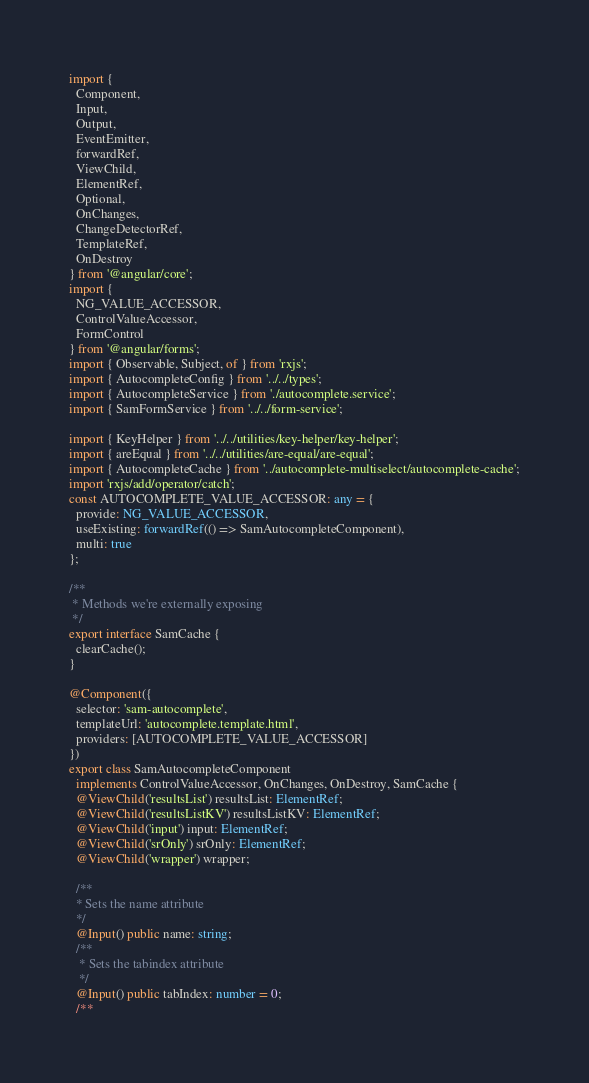<code> <loc_0><loc_0><loc_500><loc_500><_TypeScript_>import {
  Component,
  Input,
  Output,
  EventEmitter,
  forwardRef,
  ViewChild,
  ElementRef,
  Optional,
  OnChanges,
  ChangeDetectorRef,
  TemplateRef,
  OnDestroy
} from '@angular/core';
import {
  NG_VALUE_ACCESSOR,
  ControlValueAccessor,
  FormControl
} from '@angular/forms';
import { Observable, Subject, of } from 'rxjs';
import { AutocompleteConfig } from '../../types';
import { AutocompleteService } from './autocomplete.service';
import { SamFormService } from '../../form-service';

import { KeyHelper } from '../../utilities/key-helper/key-helper';
import { areEqual } from '../../utilities/are-equal/are-equal';
import { AutocompleteCache } from '../autocomplete-multiselect/autocomplete-cache';
import 'rxjs/add/operator/catch';
const AUTOCOMPLETE_VALUE_ACCESSOR: any = {
  provide: NG_VALUE_ACCESSOR,
  useExisting: forwardRef(() => SamAutocompleteComponent),
  multi: true
};

/**
 * Methods we're externally exposing
 */
export interface SamCache {
  clearCache();
}

@Component({
  selector: 'sam-autocomplete',
  templateUrl: 'autocomplete.template.html',
  providers: [AUTOCOMPLETE_VALUE_ACCESSOR]
})
export class SamAutocompleteComponent
  implements ControlValueAccessor, OnChanges, OnDestroy, SamCache {
  @ViewChild('resultsList') resultsList: ElementRef;
  @ViewChild('resultsListKV') resultsListKV: ElementRef;
  @ViewChild('input') input: ElementRef;
  @ViewChild('srOnly') srOnly: ElementRef;
  @ViewChild('wrapper') wrapper;

  /**
  * Sets the name attribute
  */
  @Input() public name: string;
  /**
   * Sets the tabindex attribute
   */
  @Input() public tabIndex: number = 0;
  /**</code> 